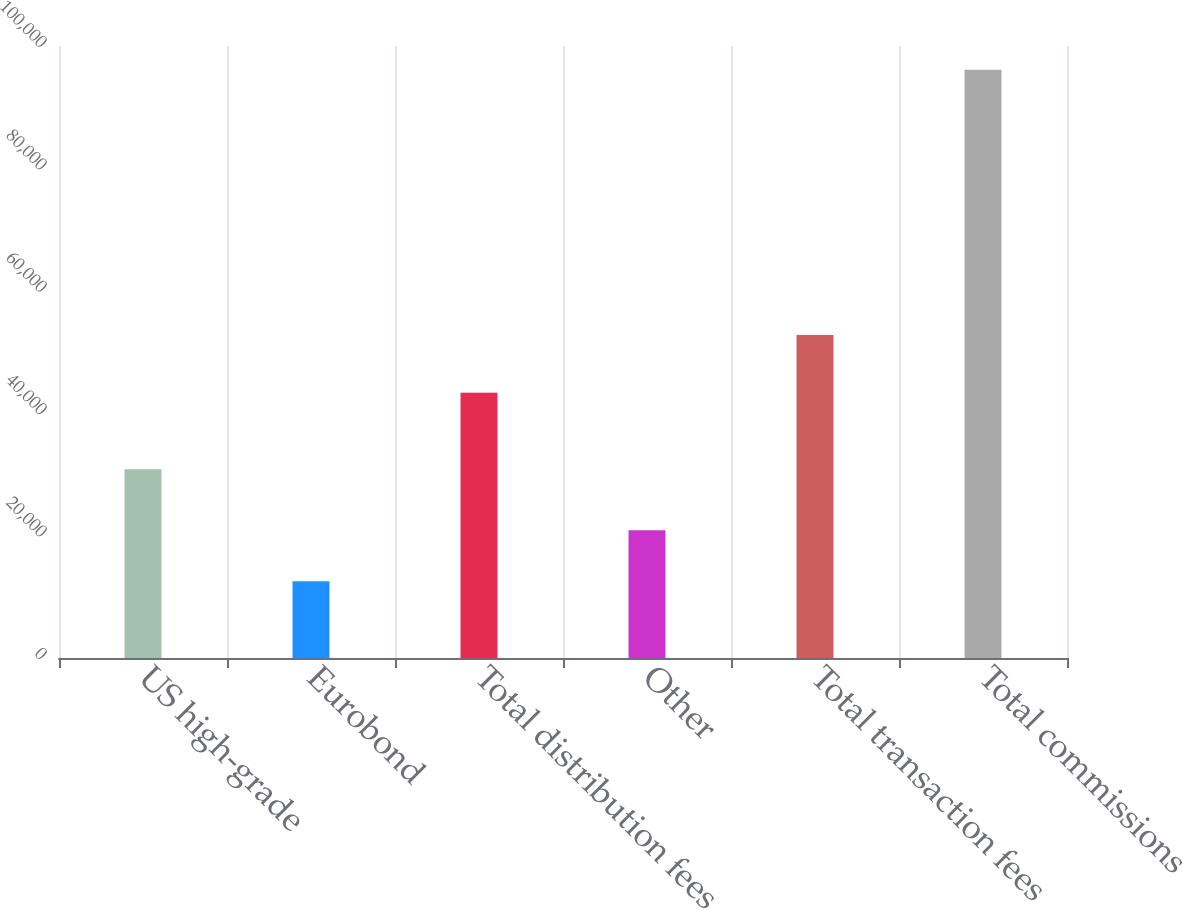Convert chart to OTSL. <chart><loc_0><loc_0><loc_500><loc_500><bar_chart><fcel>US high-grade<fcel>Eurobond<fcel>Total distribution fees<fcel>Other<fcel>Total transaction fees<fcel>Total commissions<nl><fcel>30831<fcel>12526<fcel>43357<fcel>20886.6<fcel>52775<fcel>96132<nl></chart> 